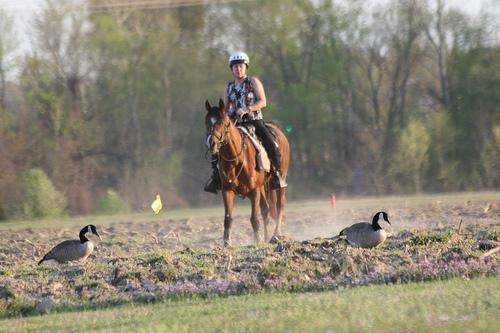How many ducks are there?
Give a very brief answer. 2. 